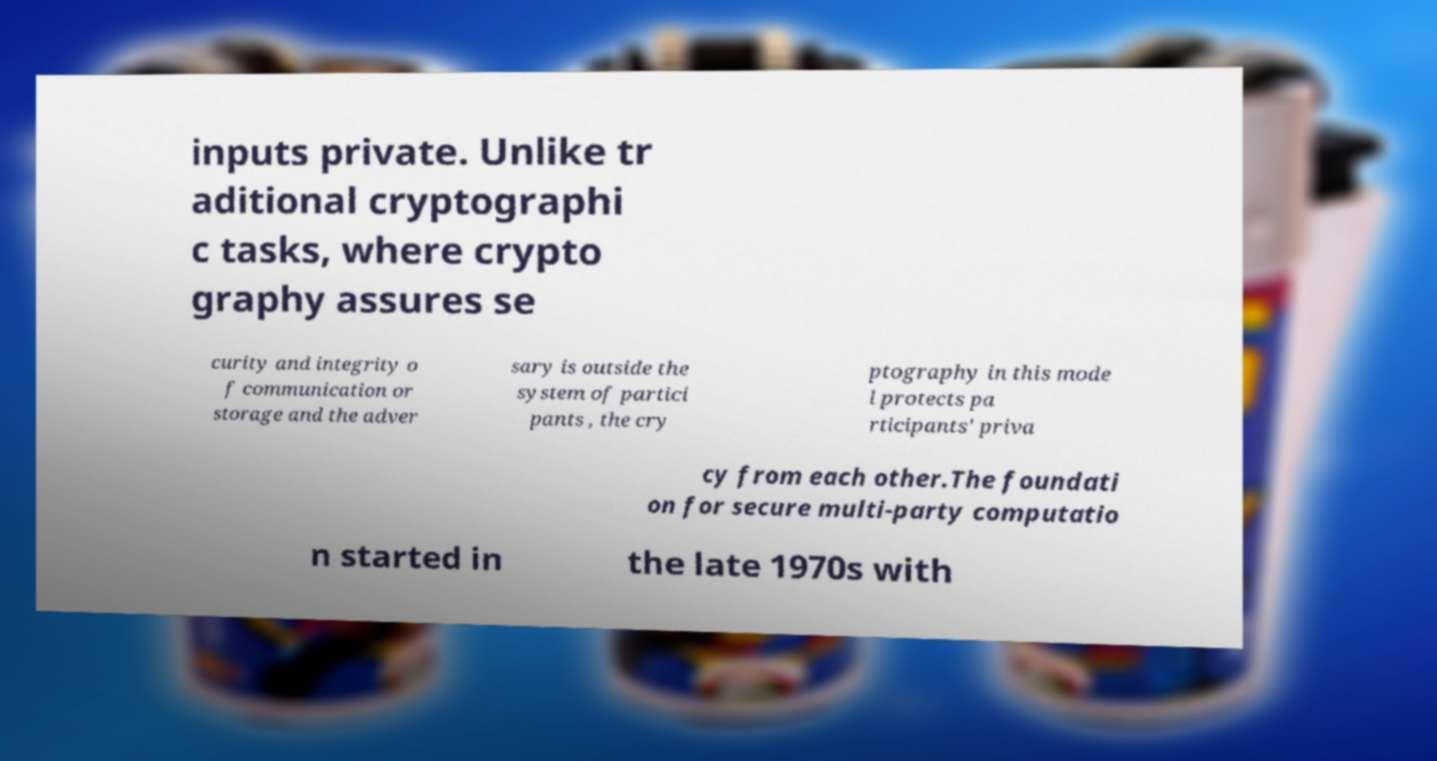Please identify and transcribe the text found in this image. inputs private. Unlike tr aditional cryptographi c tasks, where crypto graphy assures se curity and integrity o f communication or storage and the adver sary is outside the system of partici pants , the cry ptography in this mode l protects pa rticipants' priva cy from each other.The foundati on for secure multi-party computatio n started in the late 1970s with 